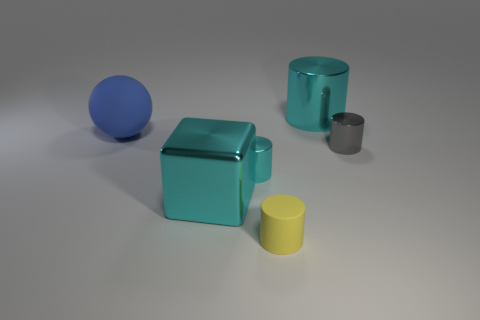Add 2 tiny cyan cylinders. How many objects exist? 8 Subtract all matte cylinders. How many cylinders are left? 3 Subtract all blue blocks. How many cyan cylinders are left? 2 Subtract 1 cubes. How many cubes are left? 0 Subtract all yellow cylinders. How many cylinders are left? 3 Subtract all spheres. How many objects are left? 5 Add 1 large blue spheres. How many large blue spheres are left? 2 Add 6 large cylinders. How many large cylinders exist? 7 Subtract 0 green cylinders. How many objects are left? 6 Subtract all blue cylinders. Subtract all yellow balls. How many cylinders are left? 4 